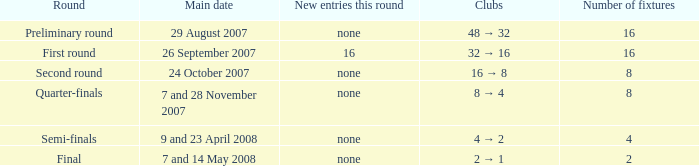What is the New entries this round when the round is the semi-finals? None. 